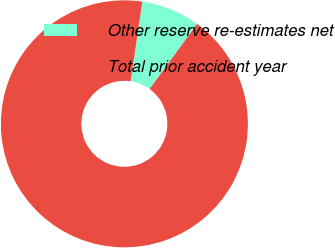Convert chart. <chart><loc_0><loc_0><loc_500><loc_500><pie_chart><fcel>Other reserve re-estimates net<fcel>Total prior accident year<nl><fcel>7.69%<fcel>92.31%<nl></chart> 